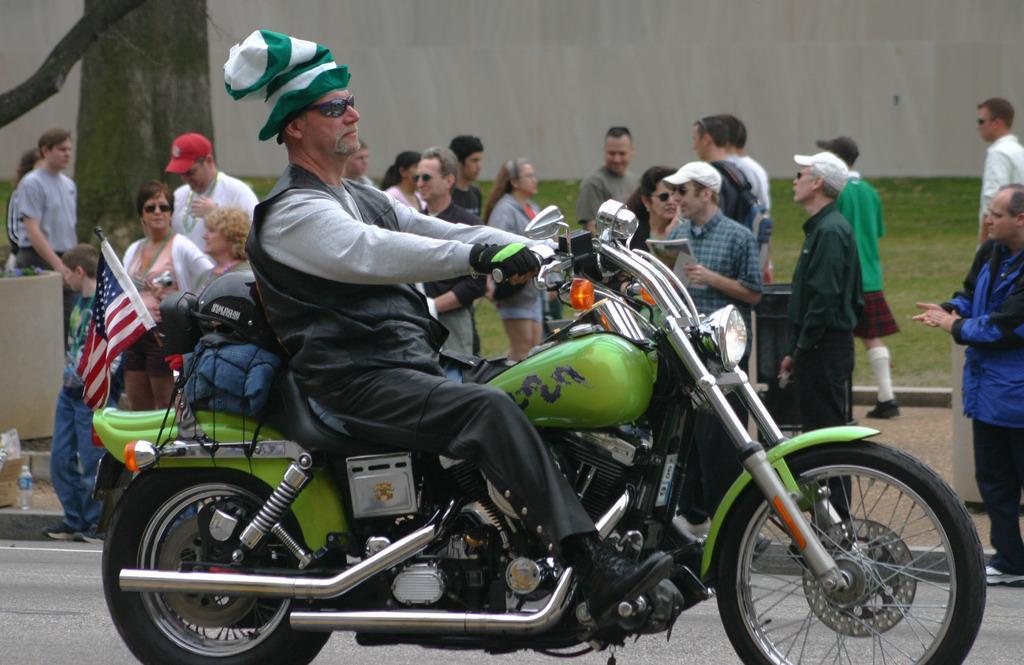Describe this image in one or two sentences. Here we can see a old man riding a motorbike with a flag behind it and behind it we can see group of people standing 